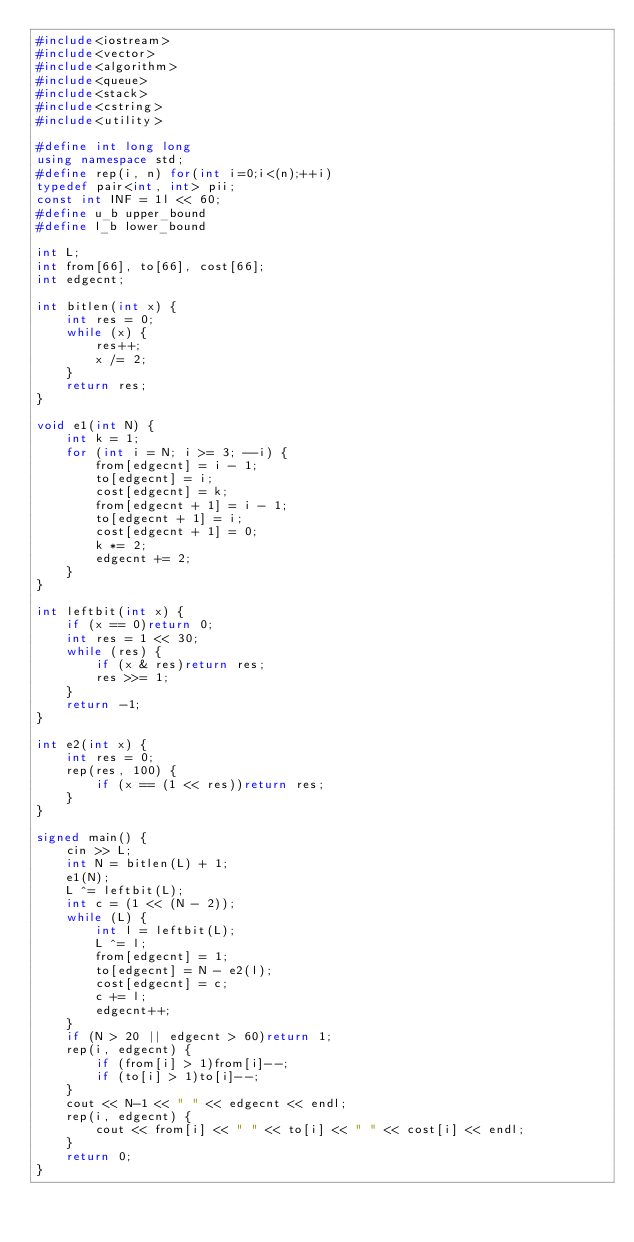Convert code to text. <code><loc_0><loc_0><loc_500><loc_500><_C++_>#include<iostream>
#include<vector>
#include<algorithm>
#include<queue>
#include<stack>
#include<cstring>
#include<utility>

#define int long long
using namespace std;
#define rep(i, n) for(int i=0;i<(n);++i)
typedef pair<int, int> pii;
const int INF = 1l << 60;
#define u_b upper_bound
#define l_b lower_bound

int L;
int from[66], to[66], cost[66];
int edgecnt;

int bitlen(int x) {
    int res = 0;
    while (x) {
        res++;
        x /= 2;
    }
    return res;
}

void e1(int N) {
    int k = 1;
    for (int i = N; i >= 3; --i) {
        from[edgecnt] = i - 1;
        to[edgecnt] = i;
        cost[edgecnt] = k;
        from[edgecnt + 1] = i - 1;
        to[edgecnt + 1] = i;
        cost[edgecnt + 1] = 0;
        k *= 2;
        edgecnt += 2;
    }
}

int leftbit(int x) {
    if (x == 0)return 0;
    int res = 1 << 30;
    while (res) {
        if (x & res)return res;
        res >>= 1;
    }
    return -1;
}

int e2(int x) {
    int res = 0;
    rep(res, 100) {
        if (x == (1 << res))return res;
    }
}

signed main() {
    cin >> L;
    int N = bitlen(L) + 1;
    e1(N);
    L ^= leftbit(L);
    int c = (1 << (N - 2));
    while (L) {
        int l = leftbit(L);
        L ^= l;
        from[edgecnt] = 1;
        to[edgecnt] = N - e2(l);
        cost[edgecnt] = c;
        c += l;
        edgecnt++;
    }
    if (N > 20 || edgecnt > 60)return 1;
    rep(i, edgecnt) {
        if (from[i] > 1)from[i]--;
        if (to[i] > 1)to[i]--;
    }
    cout << N-1 << " " << edgecnt << endl;
    rep(i, edgecnt) {
        cout << from[i] << " " << to[i] << " " << cost[i] << endl;
    }
    return 0;
}
</code> 